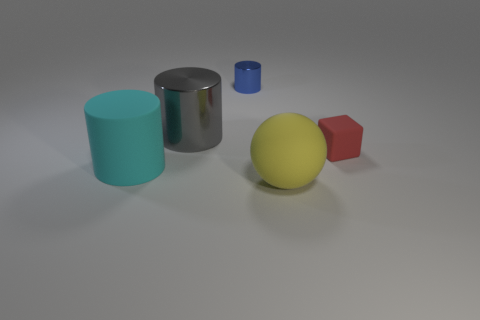Add 4 big things. How many objects exist? 9 Subtract all cylinders. How many objects are left? 2 Add 3 small blocks. How many small blocks are left? 4 Add 1 small metal objects. How many small metal objects exist? 2 Subtract 1 cyan cylinders. How many objects are left? 4 Subtract all large gray cylinders. Subtract all large yellow balls. How many objects are left? 3 